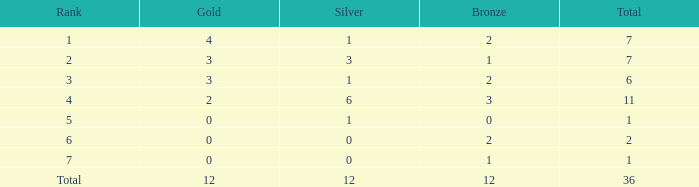What is the largest total for a team with fewer than 12 bronze, 1 silver and 0 gold medals? 1.0. 